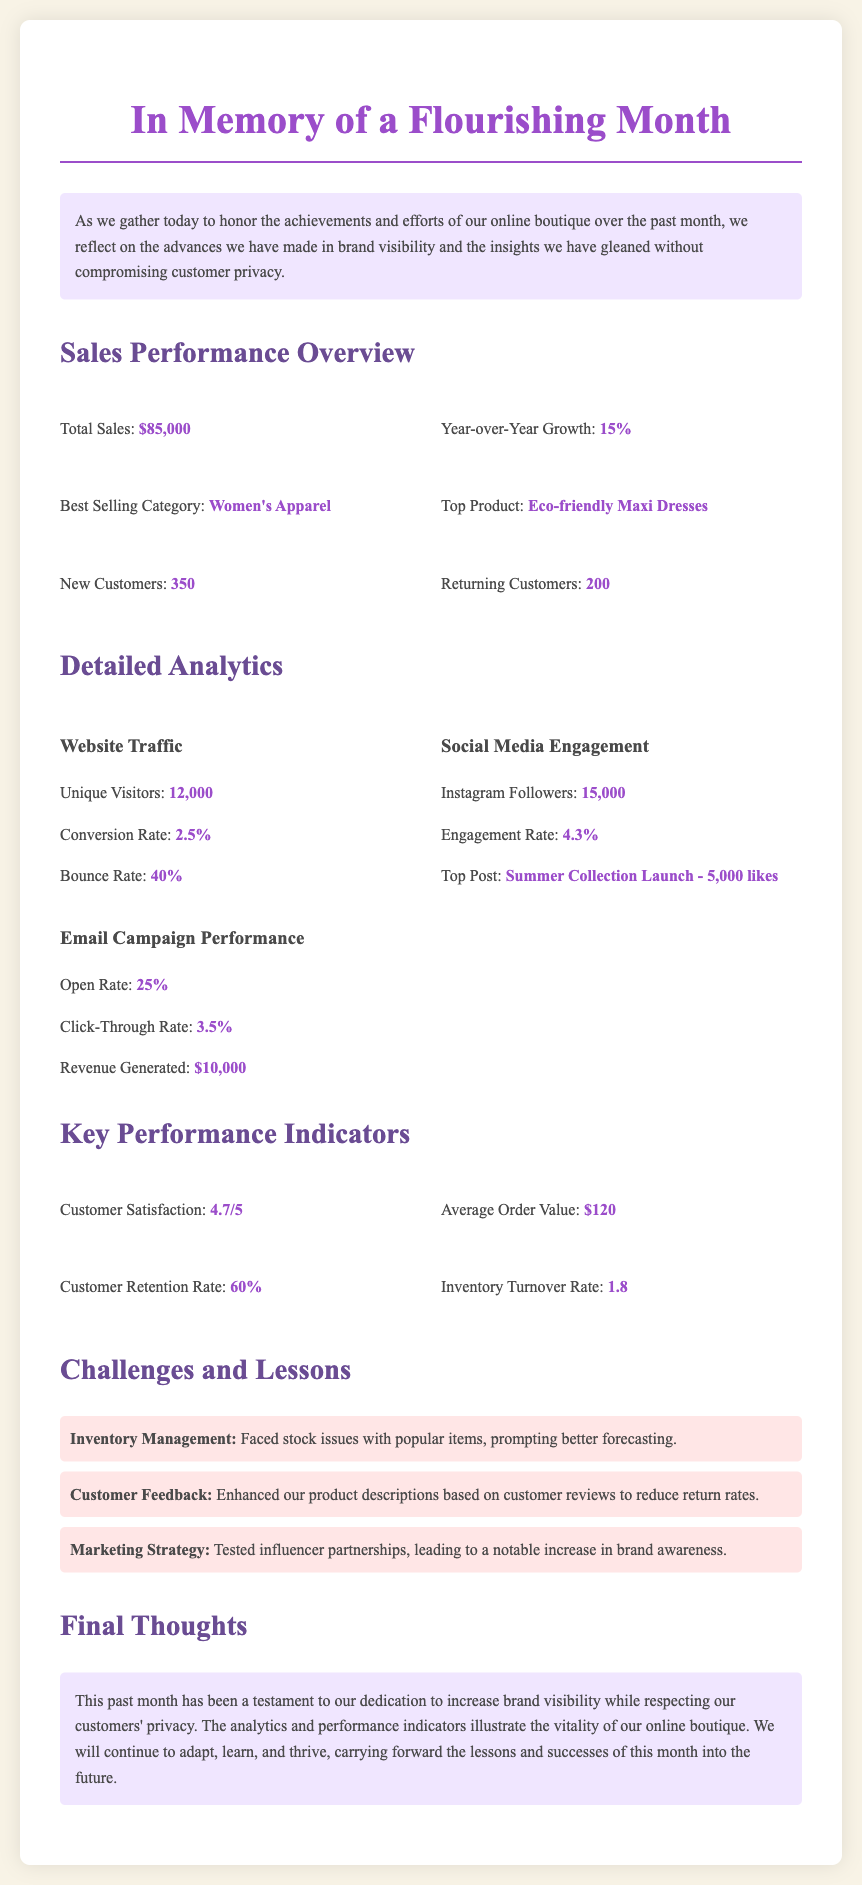What was the total sales amount? The total sales amount is clearly stated in the document as $85,000.
Answer: $85,000 What is the best selling category? The document specifies that Women’s Apparel is the best selling category.
Answer: Women's Apparel What was the year-over-year growth? The year-over-year growth is provided in the document, which is 15%.
Answer: 15% How many unique visitors were there? The document notes that there were 12,000 unique visitors to the website.
Answer: 12,000 What is the customer satisfaction rating? The customer satisfaction rating is listed in the document as 4.7 out of 5.
Answer: 4.7/5 What lesson was learned regarding marketing strategy? The document indicates that testing influencer partnerships led to increased brand awareness, indicating a lesson learned.
Answer: Influencer partnerships What was the average order value? The average order value mentioned in the document is $120.
Answer: $120 How many new customers were acquired? The document states that 350 new customers were acquired during the month.
Answer: 350 What is the revenue generated from email campaigns? The document mentions that the revenue generated from email campaigns is $10,000.
Answer: $10,000 What was the conversion rate? The conversion rate is specified in the document as 2.5%.
Answer: 2.5% 